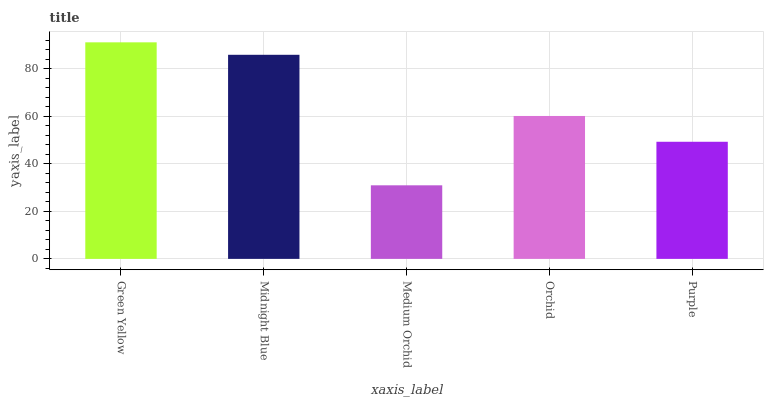Is Medium Orchid the minimum?
Answer yes or no. Yes. Is Green Yellow the maximum?
Answer yes or no. Yes. Is Midnight Blue the minimum?
Answer yes or no. No. Is Midnight Blue the maximum?
Answer yes or no. No. Is Green Yellow greater than Midnight Blue?
Answer yes or no. Yes. Is Midnight Blue less than Green Yellow?
Answer yes or no. Yes. Is Midnight Blue greater than Green Yellow?
Answer yes or no. No. Is Green Yellow less than Midnight Blue?
Answer yes or no. No. Is Orchid the high median?
Answer yes or no. Yes. Is Orchid the low median?
Answer yes or no. Yes. Is Midnight Blue the high median?
Answer yes or no. No. Is Green Yellow the low median?
Answer yes or no. No. 